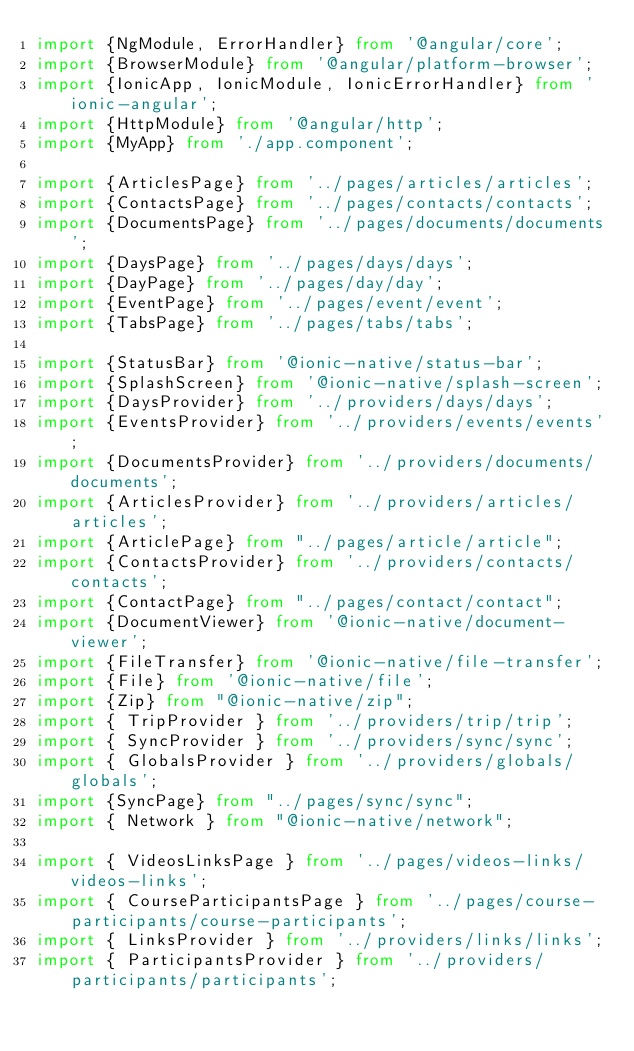Convert code to text. <code><loc_0><loc_0><loc_500><loc_500><_TypeScript_>import {NgModule, ErrorHandler} from '@angular/core';
import {BrowserModule} from '@angular/platform-browser';
import {IonicApp, IonicModule, IonicErrorHandler} from 'ionic-angular';
import {HttpModule} from '@angular/http';
import {MyApp} from './app.component';

import {ArticlesPage} from '../pages/articles/articles';
import {ContactsPage} from '../pages/contacts/contacts';
import {DocumentsPage} from '../pages/documents/documents';
import {DaysPage} from '../pages/days/days';
import {DayPage} from '../pages/day/day';
import {EventPage} from '../pages/event/event';
import {TabsPage} from '../pages/tabs/tabs';

import {StatusBar} from '@ionic-native/status-bar';
import {SplashScreen} from '@ionic-native/splash-screen';
import {DaysProvider} from '../providers/days/days';
import {EventsProvider} from '../providers/events/events';
import {DocumentsProvider} from '../providers/documents/documents';
import {ArticlesProvider} from '../providers/articles/articles';
import {ArticlePage} from "../pages/article/article";
import {ContactsProvider} from '../providers/contacts/contacts';
import {ContactPage} from "../pages/contact/contact";
import {DocumentViewer} from '@ionic-native/document-viewer';
import {FileTransfer} from '@ionic-native/file-transfer';
import {File} from '@ionic-native/file';
import {Zip} from "@ionic-native/zip";
import { TripProvider } from '../providers/trip/trip';
import { SyncProvider } from '../providers/sync/sync';
import { GlobalsProvider } from '../providers/globals/globals';
import {SyncPage} from "../pages/sync/sync";
import { Network } from "@ionic-native/network";

import { VideosLinksPage } from '../pages/videos-links/videos-links';
import { CourseParticipantsPage } from '../pages/course-participants/course-participants';
import { LinksProvider } from '../providers/links/links';
import { ParticipantsProvider } from '../providers/participants/participants';</code> 